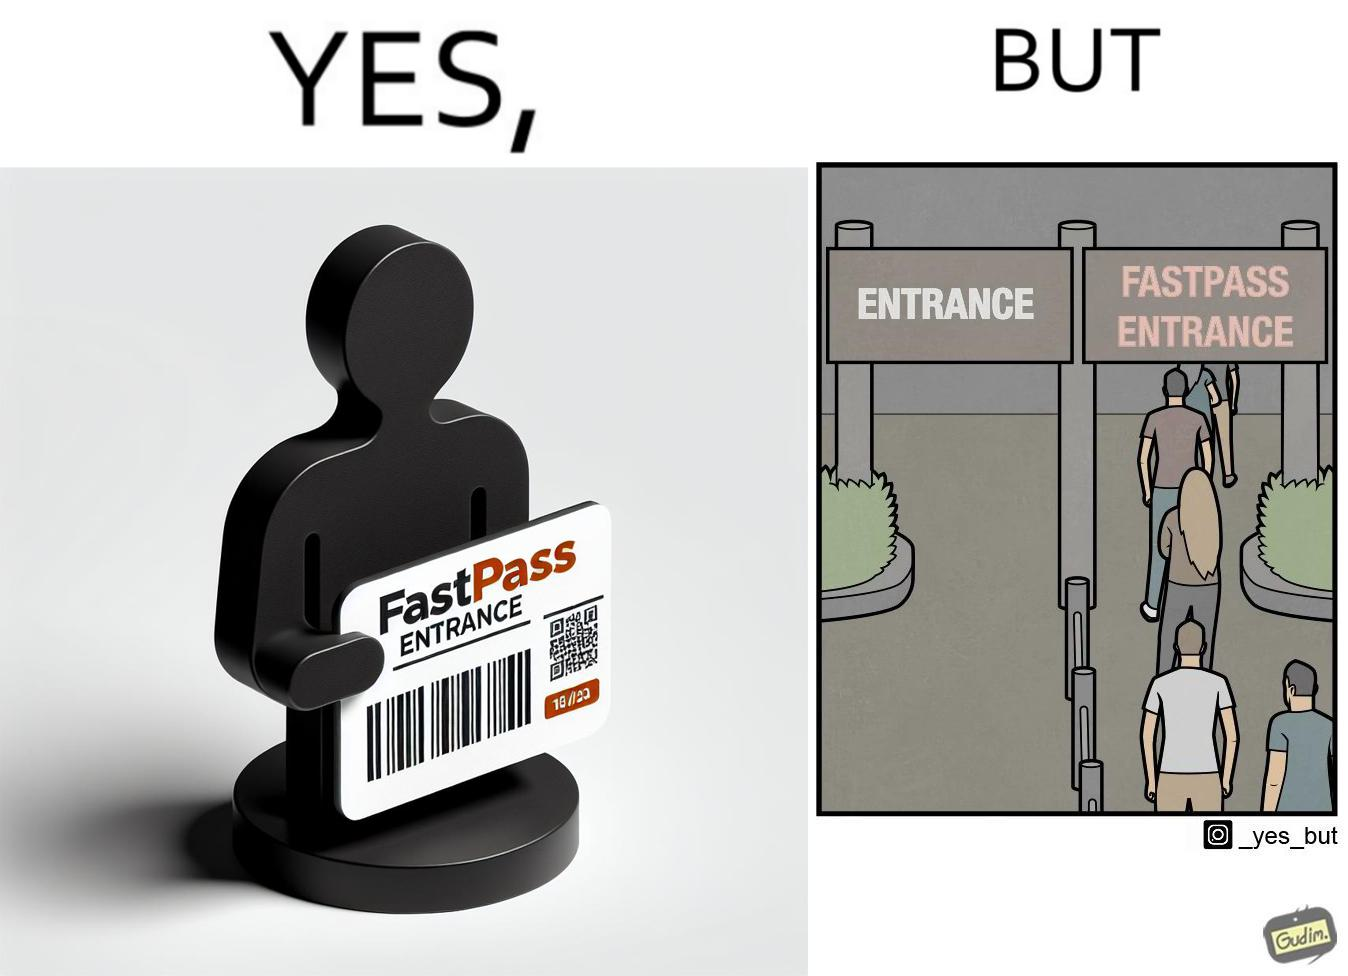Describe the satirical element in this image. The image is ironic, because fast pass entrance was meant for people to pass the gate fast but as more no. of people bought the pass due to which the queue has become longer and it becomes slow and time consuming 